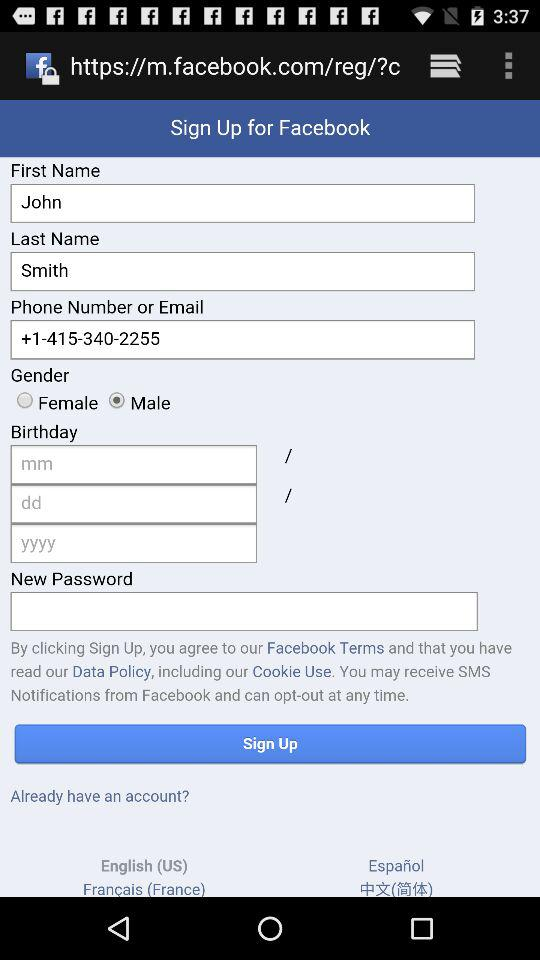What is the first name? The first name is John. 